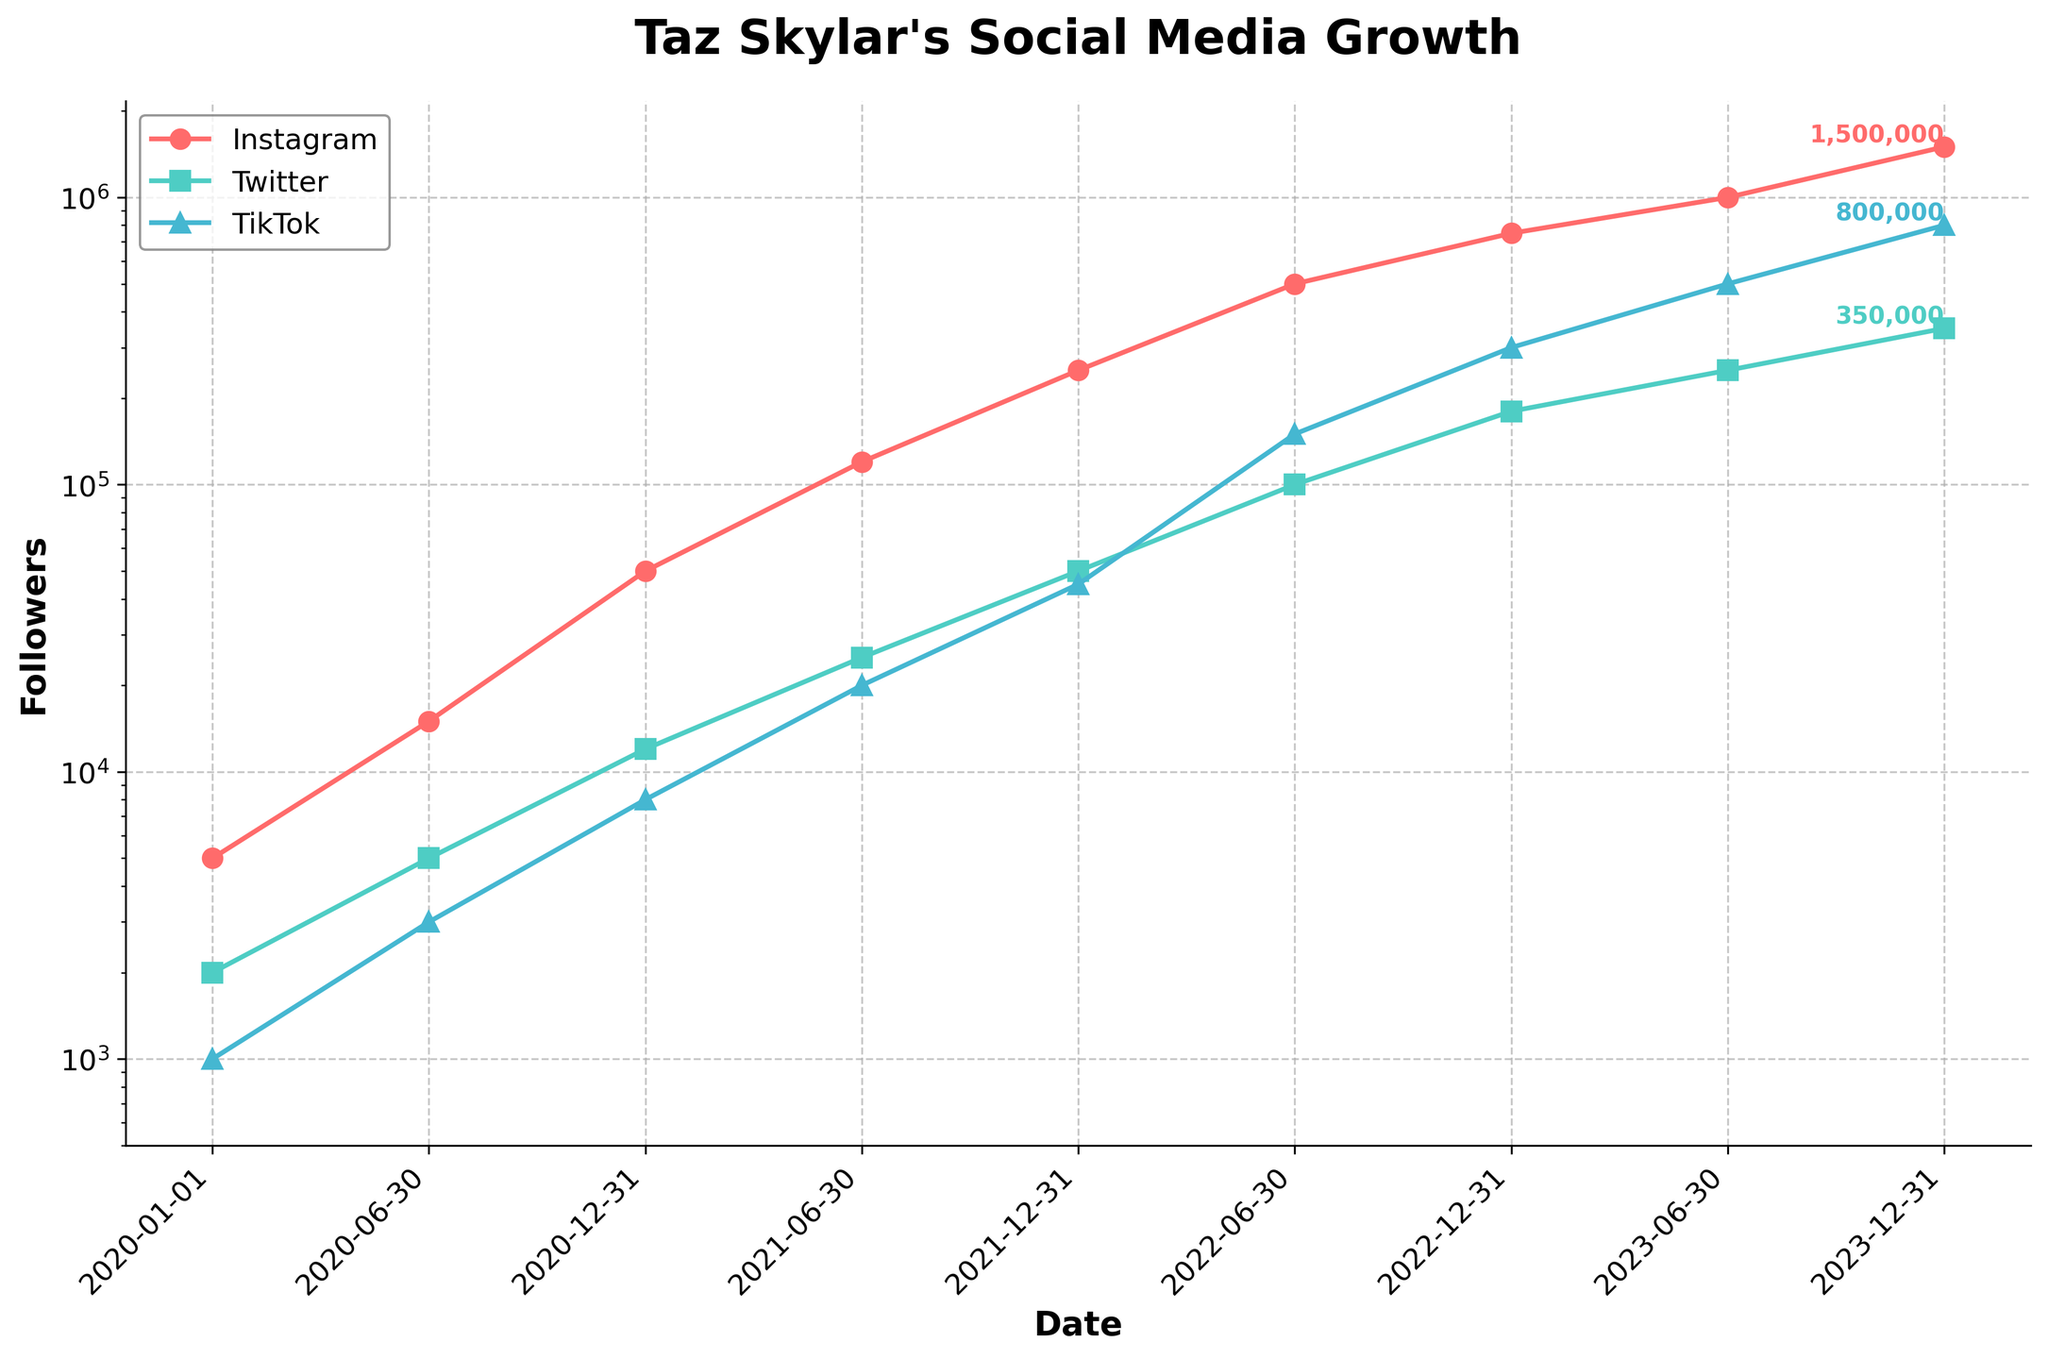What was Taz Skylar's Instagram follower count at the end of 2020? Looking at the Instagram data point for 2020-12-31 on the graph, you can see that it is marked at 50,000 followers.
Answer: 50,000 During which period did Taz Skylar's TikTok followers grow the most? Observe the TikTok data points and look at the differences between consecutive points. The period from 2020-06-30 (3,000 followers) to 2020-12-31 (8,000 followers) shows a significant increase of 5,000 followers.
Answer: 2020-06-30 to 2020-12-31 How many more Instagram followers did Taz Skylar have compared to Twitter followers on 2023-12-31? Look at the data for the specified date, where Instagram shows 1,500,000 followers and Twitter shows 350,000 followers. The difference is 1,500,000 - 350,000 = 1,150,000 followers.
Answer: 1,150,000 Which platform showed the highest growth rate between 2022-06-30 and 2023-06-30? To determine the growth rate, calculate the difference in follower counts for each platform: 
- Instagram: 1,000,000 - 500,000 = 500,000
- Twitter: 250,000 - 100,000 = 150,000
- TikTok: 500,000 - 150,000 = 350,000
Instagram shows the highest growth rate with an increase of 500,000 followers.
Answer: Instagram By how much did Taz Skylar's TikTok followers increase from his debut until the end of 2023? Subtract the TikTok followers at debut (1,000 on 2020-01-01) from the value at the end of 2023 (800,000 on 2023-12-31). The increase is 800,000 - 1,000 = 799,000 followers.
Answer: 799,000 Which platform consistently had the lowest number of followers throughout the shown periods? By comparing data points for all three platforms over time, Twitter always had the lowest number of followers.
Answer: Twitter What is the approximate ratio of Instagram followers to TikTok followers at the end of 2022? On 2022-12-31, Instagram had 750,000 followers and TikTok had 300,000 followers. Calculate the ratio as 750,000 to 300,000, which simplifies to 2.5:1.
Answer: 2.5:1 What trend can be observed about Taz Skylar's growth in Instagram followers over the years? Observing the plot for Instagram followers, it shows a continuous upward trend, increasing exponentially over the years.
Answer: Exponential growth 